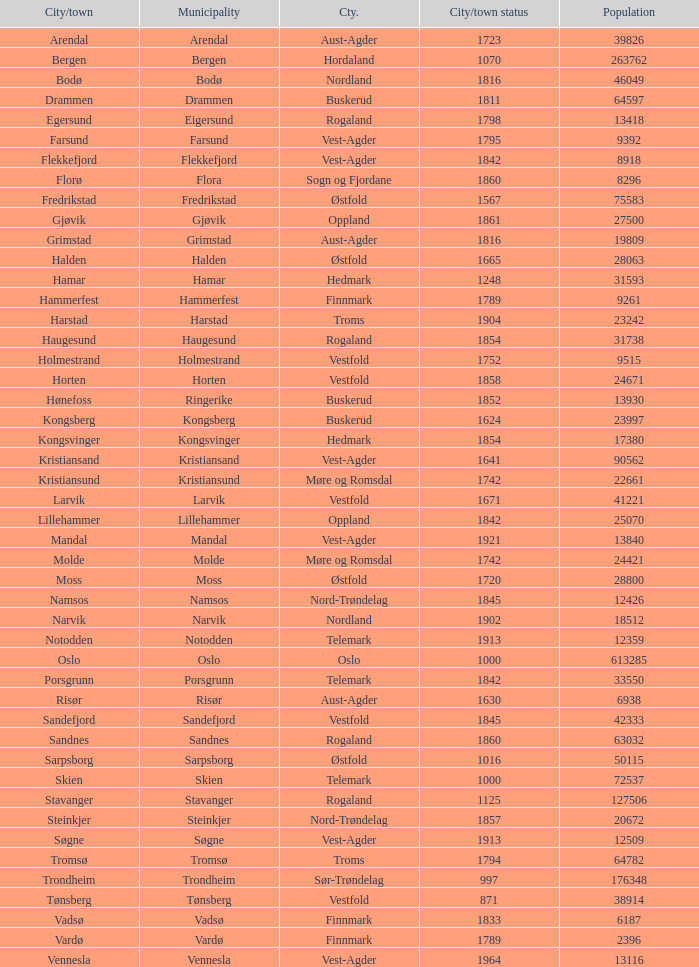What is the entire population in the city/town of arendal? 1.0. 